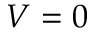<formula> <loc_0><loc_0><loc_500><loc_500>V = 0</formula> 